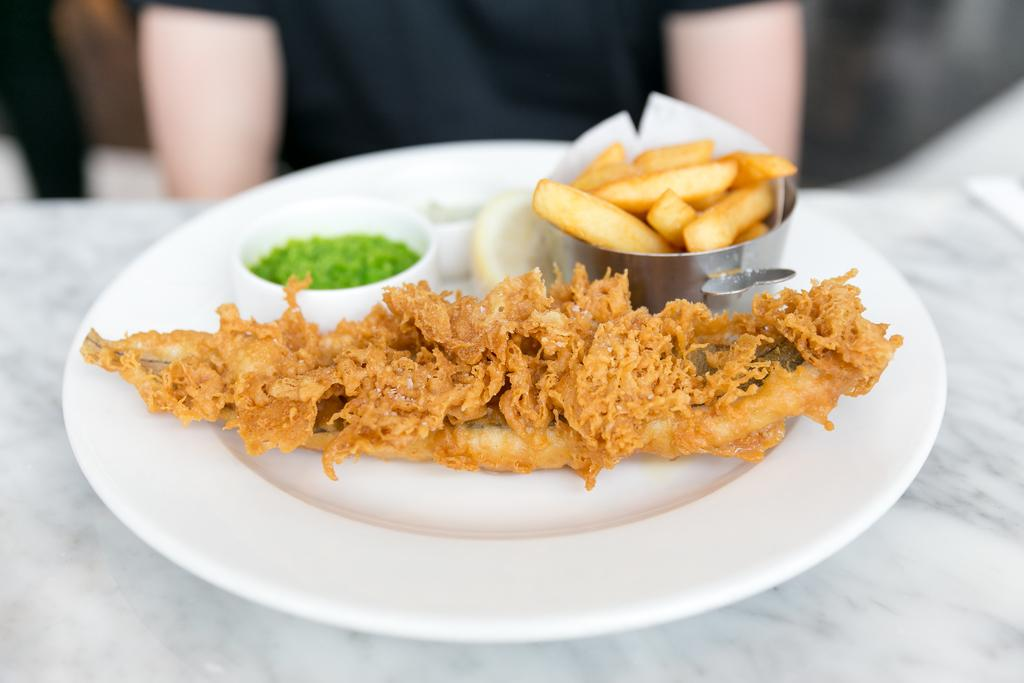What is on the plate that is visible in the image? There is food on a plate in the image. Where is the plate placed in the image? The plate is placed on a white surface. Can you describe the person visible in the background of the image? The person is visible in the background of the image, although they are truncated, meaning only a part of their body is shown. What year is depicted in the image? The image does not depict a specific year; it is a still image of a plate of food and a person in the background. What type of bird can be seen flying in the image? There are no birds visible in the image. 